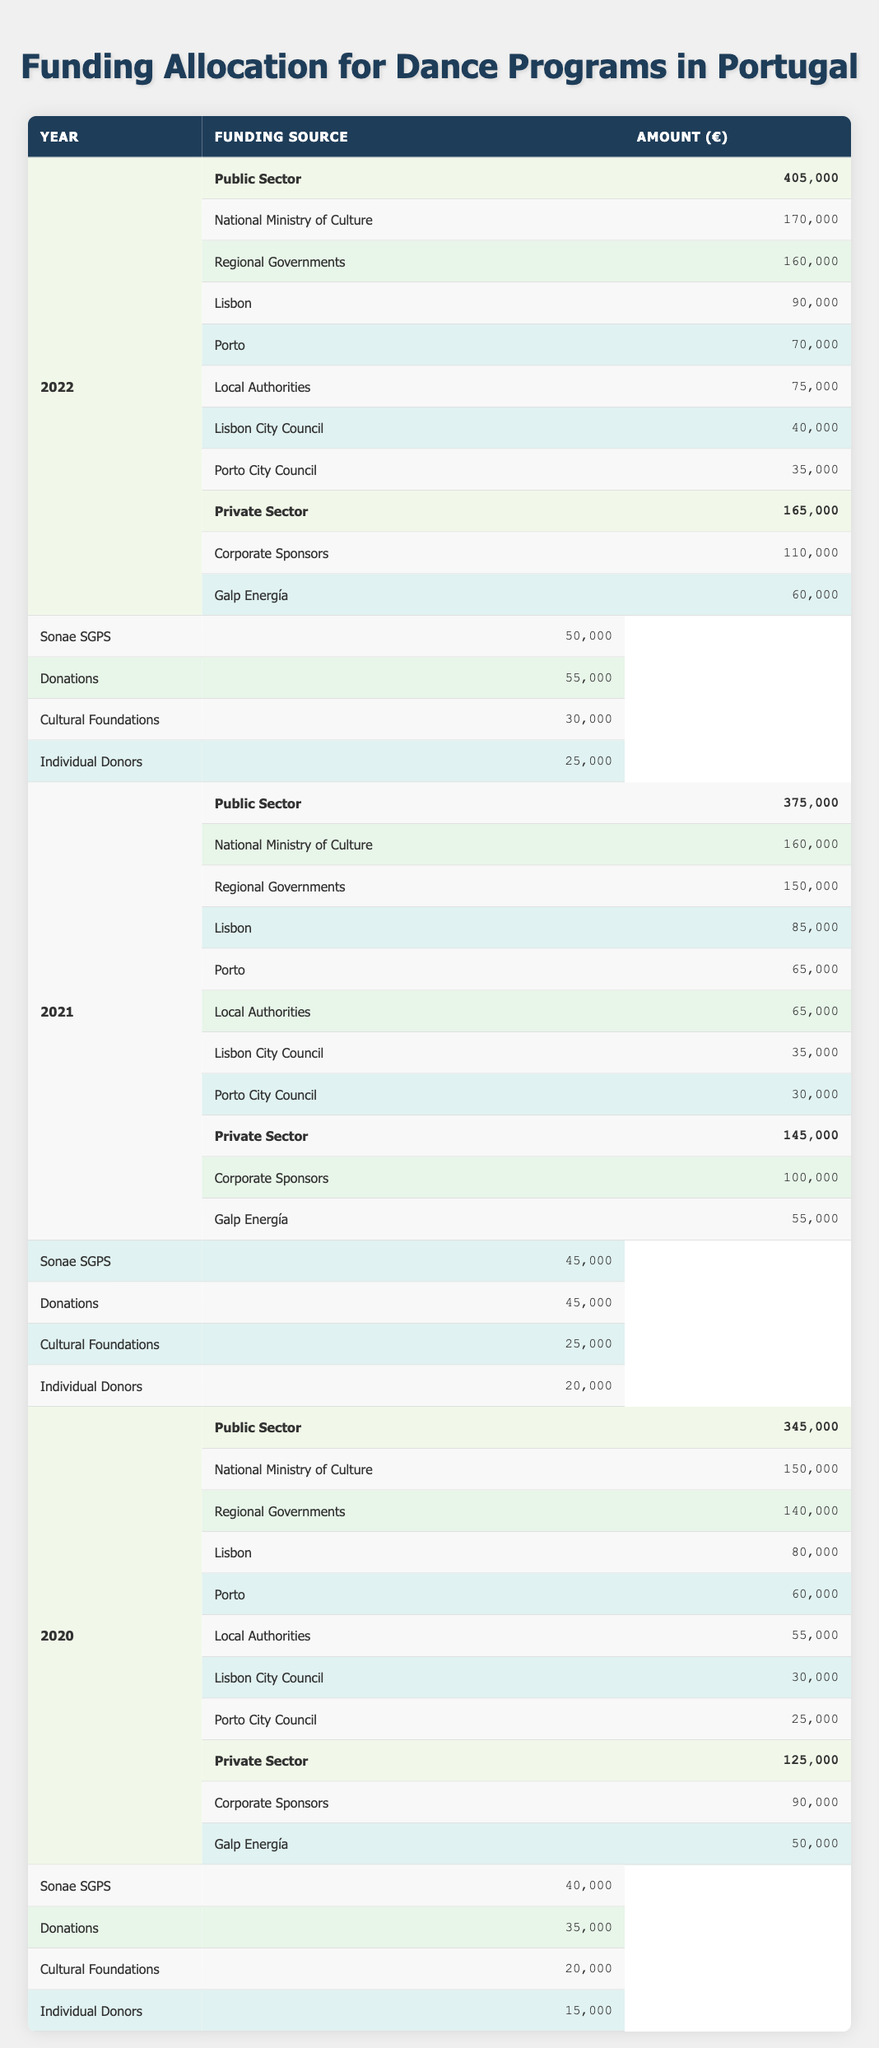What was the total public sector funding for dance programs in Portugal in 2021? In 2021, the public sector funding is comprised of several components: National Ministry of Culture (160,000), Regional Governments (150,000), and Local Authorities (65,000). Adding these values gives: 160,000 + 150,000 + 65,000 = 375,000.
Answer: 375,000 Which year saw the highest funding from corporate sponsors? The corporate sponsors' funding over the three years is as follows: in 2020, it was 90,000; in 2021, it was 100,000; and in 2022, it was 110,000. The increasing trend shows that 2022 had the highest funding from corporate sponsors.
Answer: 2022 Did the total funding for dance programs increase or decrease from 2020 to 2021? The total funding for 2020 is calculated as public sector (345,000) plus private sector (125,000), which makes 470,000. For 2021, public sector funding is 375,000 and private sector is 145,000, totaling 520,000. Comparing both, 520,000 > 470,000 shows an increase.
Answer: Increase What is the difference in funding from the National Ministry of Culture between 2020 and 2022? For 2020, the National Ministry of Culture allocated 150,000, while in 2022, it allocated 170,000. The difference can be calculated as 170,000 - 150,000 = 20,000.
Answer: 20,000 What percentage of the total funding in 2021 came from public sector sources? The total funding for 2021 is 375,000 (public) + 145,000 (private) = 520,000. The percentage from the public sector is calculated as (375,000 / 520,000) * 100, approximately equal to 72.12%.
Answer: 72.12% Was the funding from donations greater or lesser than from corporate sponsors in 2022? In 2022, donations totaled 55,000 (30,000 from Cultural Foundations and 25,000 from Individual Donors) and corporate sponsors totaled 110,000. Since 55,000 < 110,000, this indicates that donations were lesser than corporate sponsorships in 2022.
Answer: Lesser What was the average funding amount from private sector sources in 2020? In 2020, the private sector had a total of 125,000, which consists of corporate sponsors (90,000) and donations (35,000). The average can be calculated as 125,000 / 2 = 62,500.
Answer: 62,500 Which year had the lowest total funding for dance programs from the Local Authorities? Sum up the total from Local Authorities for the three years: 2020 had 55,000, 2021 had 65,000, and 2022 had 75,000. The lowest figure here is 55,000 in 2020, indicating it had the least funding from Local Authorities among the years.
Answer: 2020 